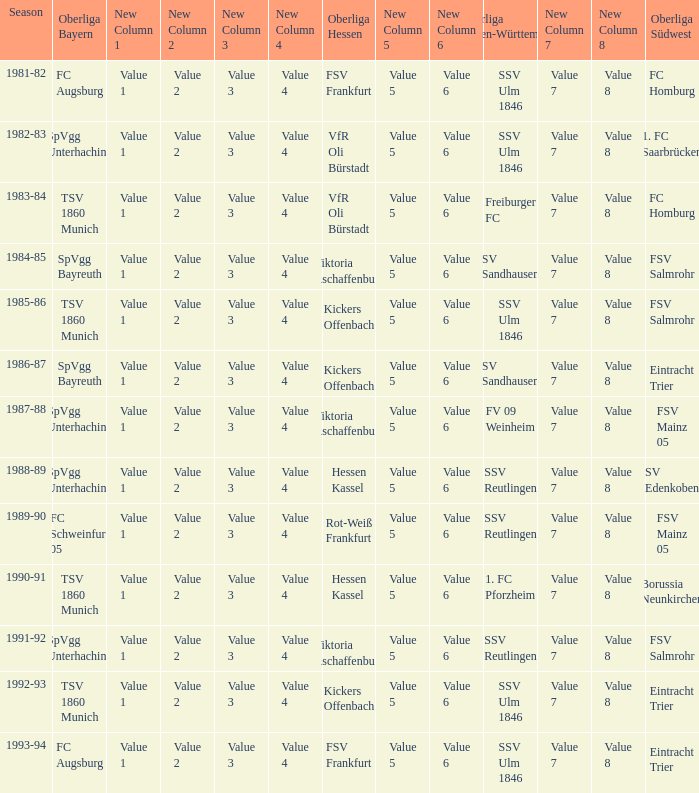Which oberliga baden-württemberg has a season of 1991-92? SSV Reutlingen. 